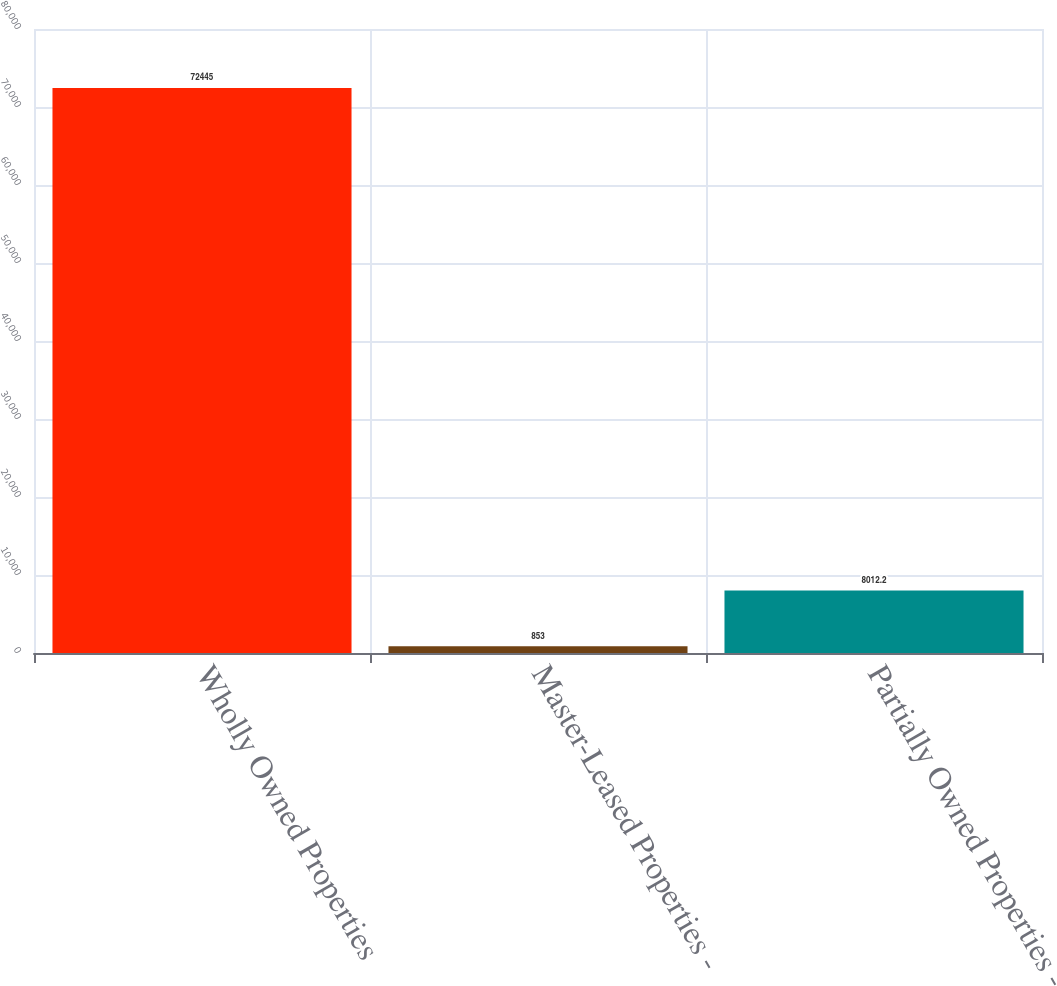Convert chart to OTSL. <chart><loc_0><loc_0><loc_500><loc_500><bar_chart><fcel>Wholly Owned Properties<fcel>Master-Leased Properties -<fcel>Partially Owned Properties -<nl><fcel>72445<fcel>853<fcel>8012.2<nl></chart> 